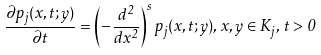Convert formula to latex. <formula><loc_0><loc_0><loc_500><loc_500>\frac { \partial p _ { j } ( x , t ; y ) } { \partial t } = \left ( - \frac { d ^ { 2 } } { d x ^ { 2 } } \right ) ^ { s } p _ { j } ( x , t ; y ) , \, x , y \in K _ { j } , \, t > 0</formula> 